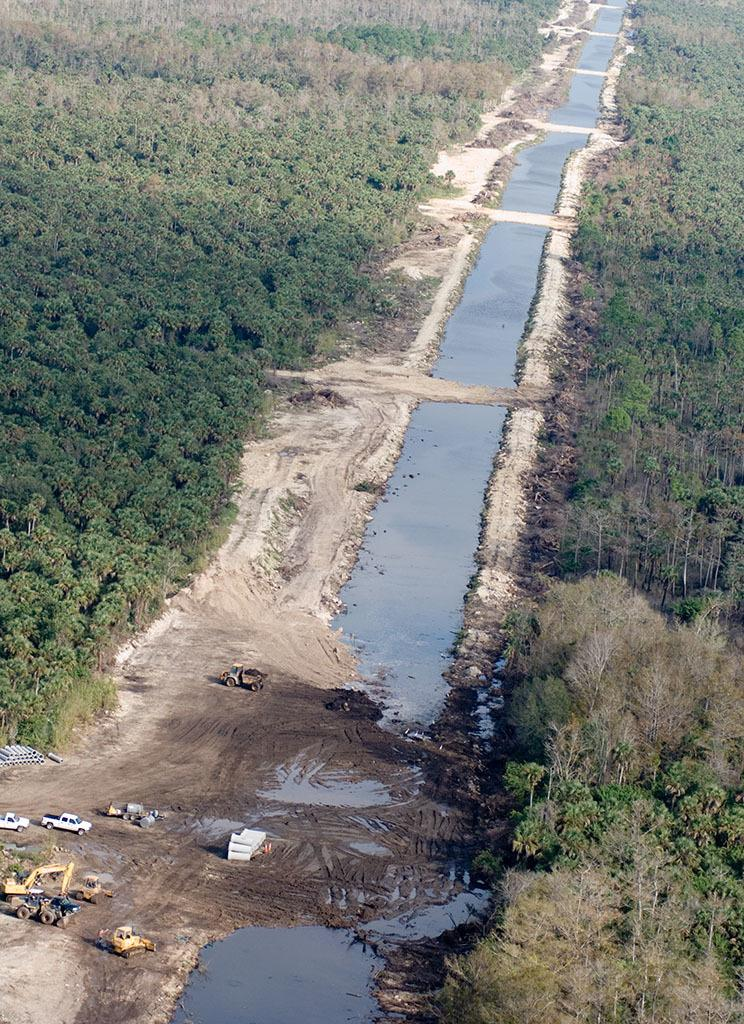What is located at the bottom of the image? There are vehicles and water at the bottom of the image. What can be seen in the middle of the image? There are trees in the middle of the image. Where is the shelf located in the image? There is no shelf present in the image. What type of arm can be seen interacting with the trees in the image? There are no arms or people present in the image; only vehicles, water, and trees are visible. 